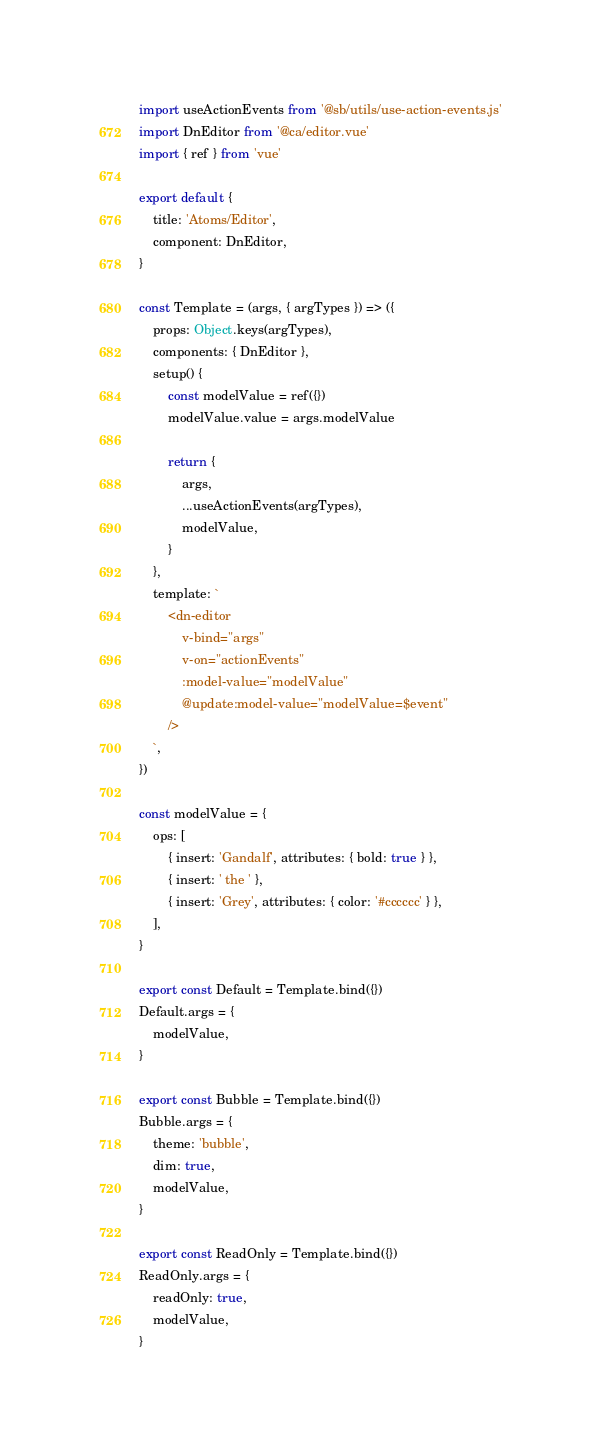<code> <loc_0><loc_0><loc_500><loc_500><_JavaScript_>import useActionEvents from '@sb/utils/use-action-events.js'
import DnEditor from '@ca/editor.vue'
import { ref } from 'vue'

export default {
    title: 'Atoms/Editor',
    component: DnEditor,
}

const Template = (args, { argTypes }) => ({
    props: Object.keys(argTypes),
    components: { DnEditor },
    setup() {
        const modelValue = ref({})
        modelValue.value = args.modelValue

        return {
            args,
            ...useActionEvents(argTypes),
            modelValue,
        }
    },
    template: `
        <dn-editor
            v-bind="args"
            v-on="actionEvents"
            :model-value="modelValue"
            @update:model-value="modelValue=$event"
        />
    `,
})

const modelValue = {
    ops: [
        { insert: 'Gandalf', attributes: { bold: true } },
        { insert: ' the ' },
        { insert: 'Grey', attributes: { color: '#cccccc' } },
    ],
}

export const Default = Template.bind({})
Default.args = {
    modelValue,
}

export const Bubble = Template.bind({})
Bubble.args = {
    theme: 'bubble',
    dim: true,
    modelValue,
}

export const ReadOnly = Template.bind({})
ReadOnly.args = {
    readOnly: true,
    modelValue,
}
</code> 